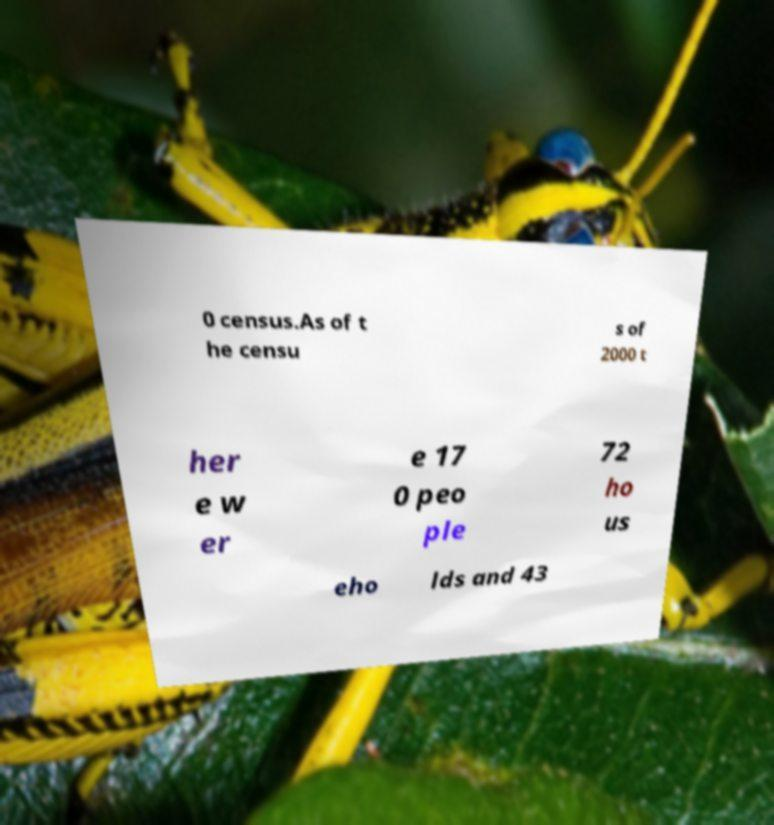There's text embedded in this image that I need extracted. Can you transcribe it verbatim? 0 census.As of t he censu s of 2000 t her e w er e 17 0 peo ple 72 ho us eho lds and 43 